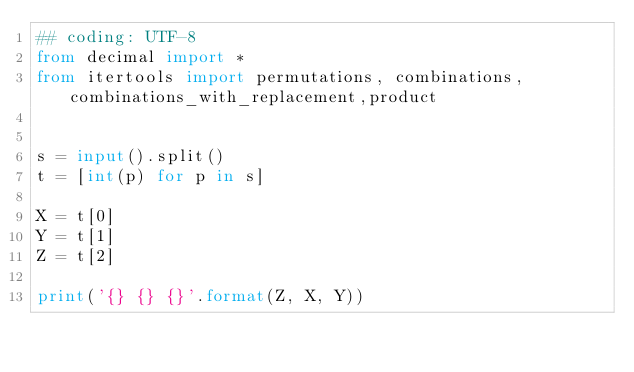<code> <loc_0><loc_0><loc_500><loc_500><_Python_>## coding: UTF-8
from decimal import *
from itertools import permutations, combinations,combinations_with_replacement,product


s = input().split()
t = [int(p) for p in s]

X = t[0]
Y = t[1]
Z = t[2]

print('{} {} {}'.format(Z, X, Y))</code> 